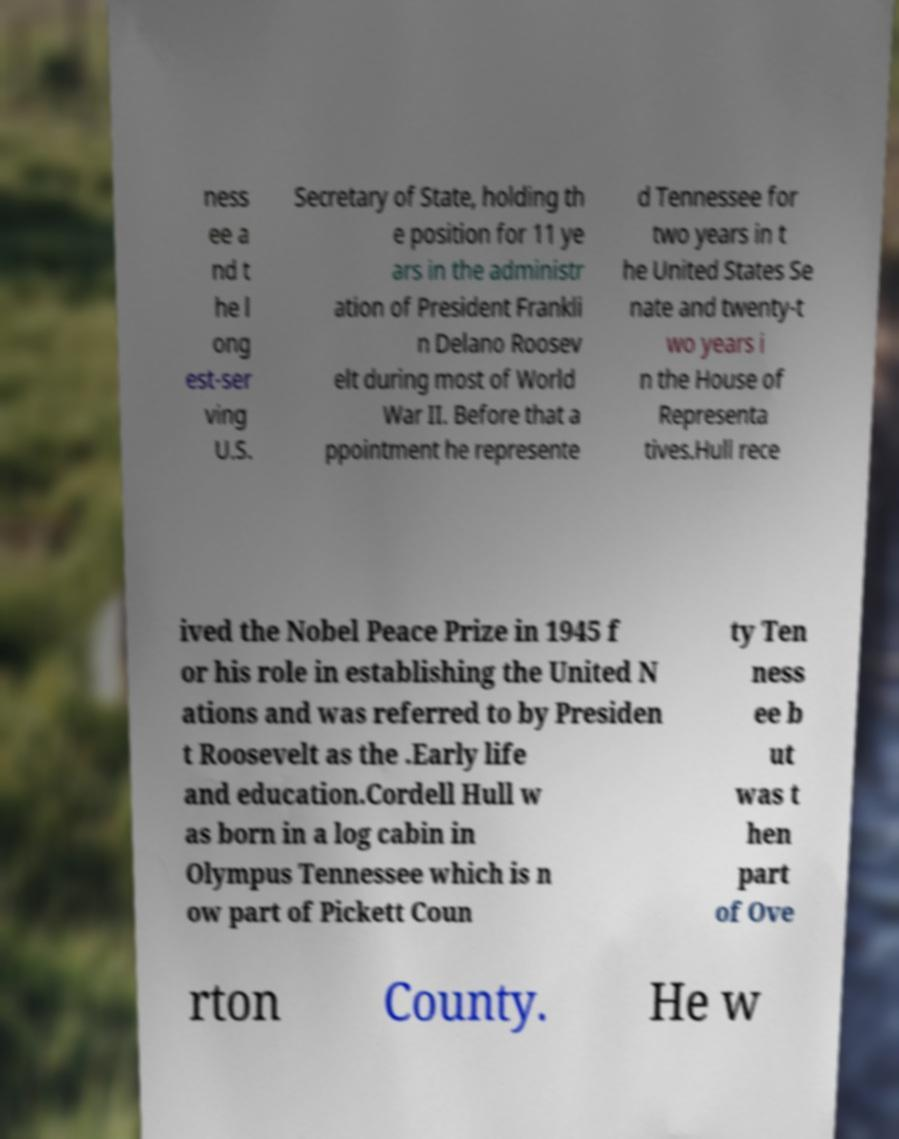Could you extract and type out the text from this image? ness ee a nd t he l ong est-ser ving U.S. Secretary of State, holding th e position for 11 ye ars in the administr ation of President Frankli n Delano Roosev elt during most of World War II. Before that a ppointment he represente d Tennessee for two years in t he United States Se nate and twenty-t wo years i n the House of Representa tives.Hull rece ived the Nobel Peace Prize in 1945 f or his role in establishing the United N ations and was referred to by Presiden t Roosevelt as the .Early life and education.Cordell Hull w as born in a log cabin in Olympus Tennessee which is n ow part of Pickett Coun ty Ten ness ee b ut was t hen part of Ove rton County. He w 